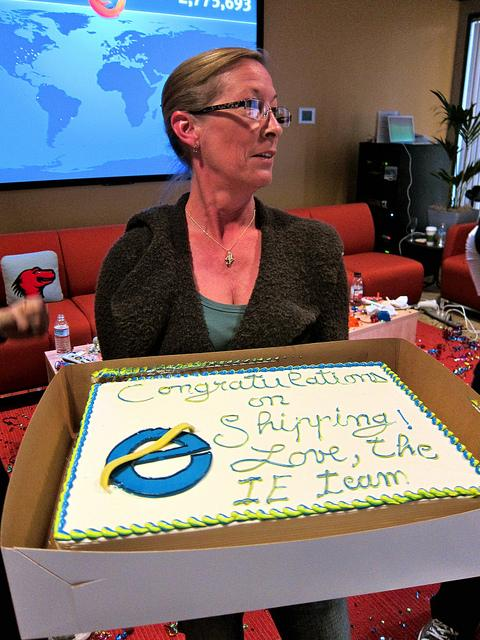Where is this cake and woman located?

Choices:
A) tech office
B) child's home
C) zoo
D) family home tech office 